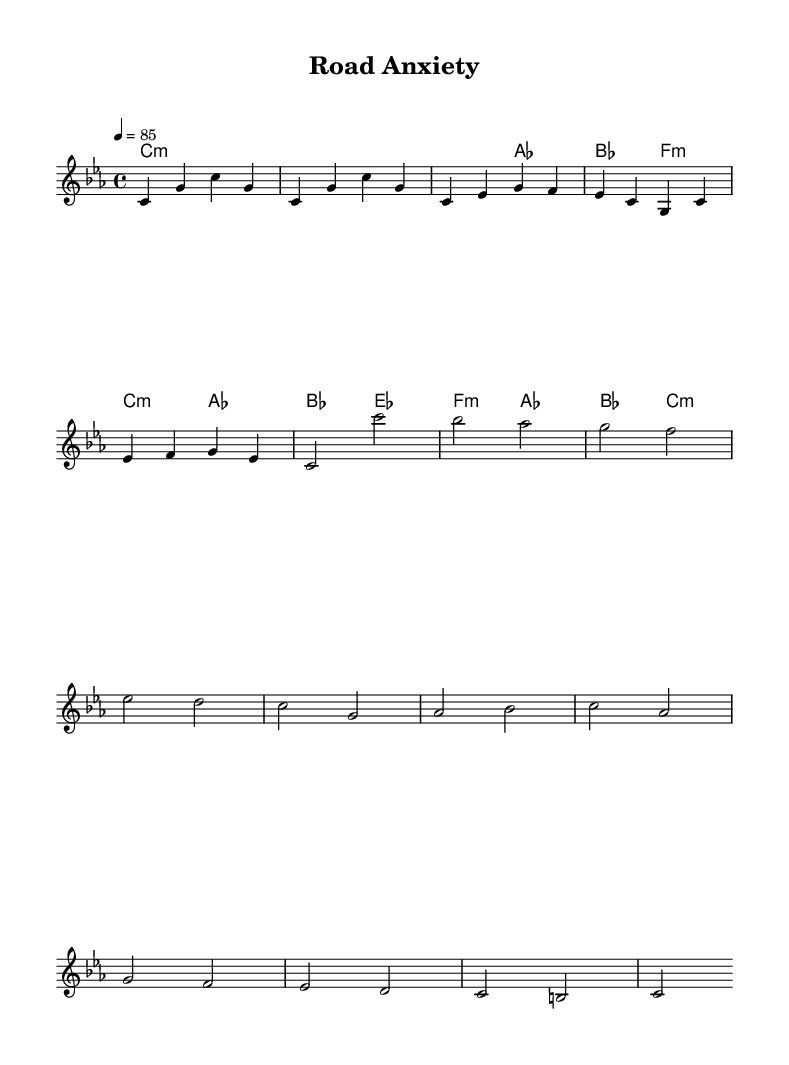What is the key signature of this music? The key signature is C minor, which contains three flat notes: B flat, E flat, and A flat. This can be determined by looking at the key signature section in the music where the flats are indicated.
Answer: C minor What is the time signature of this music? The time signature is 4/4, which means there are four beats in each measure, and a quarter note receives one beat. This is typically found at the beginning of the score.
Answer: 4/4 What is the tempo marking for this piece? The tempo marking is 85, indicating the speed at which the piece should be played. This is usually indicated with a numerical marking under the tempo indication at the beginning of the score.
Answer: 85 How many measures are in the chorus section? The chorus section consists of three measures, as indicated by counting the measures that contain the chorus melody. Each measure is separated by bar lines.
Answer: 3 measures Which chord appears in the introduction? The chord that appears in the introduction is C minor, as indicated by the chord symbols written above the melody for the introduction section.
Answer: C minor What is the last chord in the bridge section? The last chord in the bridge section is C minor, which is found by examining the chord progression written in the harmonies for that section and noting the final chord symbol.
Answer: C minor 